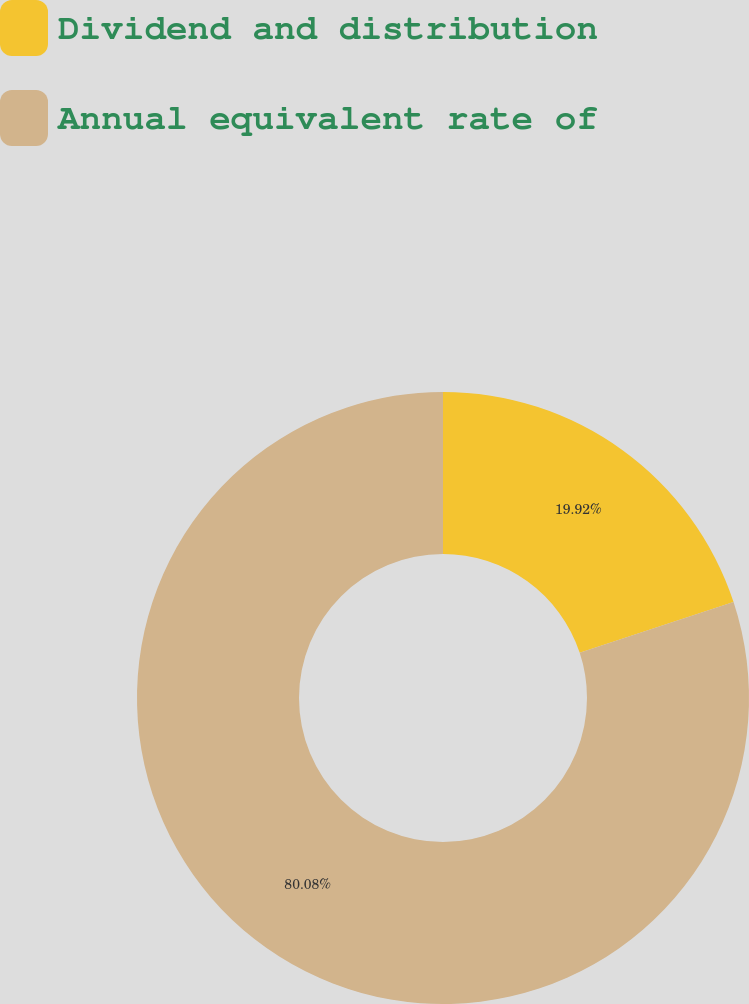Convert chart. <chart><loc_0><loc_0><loc_500><loc_500><pie_chart><fcel>Dividend and distribution<fcel>Annual equivalent rate of<nl><fcel>19.92%<fcel>80.08%<nl></chart> 